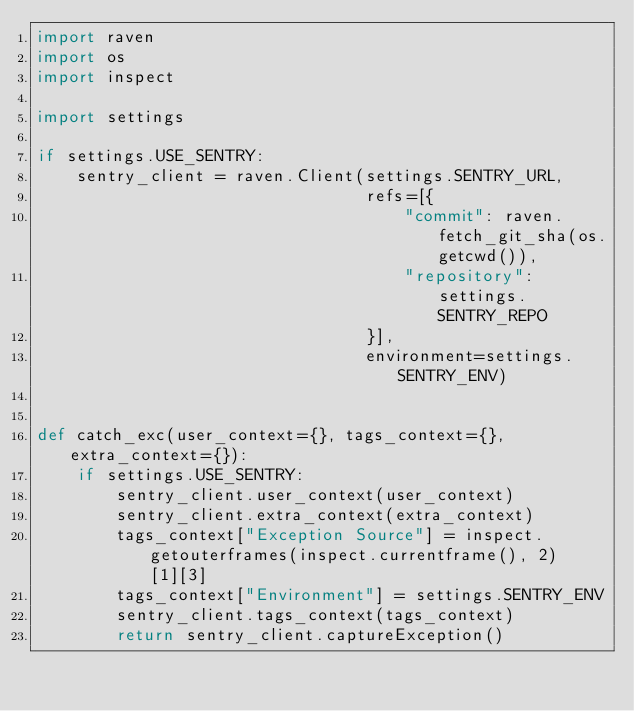<code> <loc_0><loc_0><loc_500><loc_500><_Python_>import raven
import os
import inspect

import settings

if settings.USE_SENTRY:
    sentry_client = raven.Client(settings.SENTRY_URL,
                                 refs=[{
                                     "commit": raven.fetch_git_sha(os.getcwd()),
                                     "repository": settings.SENTRY_REPO
                                 }],
                                 environment=settings.SENTRY_ENV)


def catch_exc(user_context={}, tags_context={}, extra_context={}):
    if settings.USE_SENTRY:
        sentry_client.user_context(user_context)
        sentry_client.extra_context(extra_context)
        tags_context["Exception Source"] = inspect.getouterframes(inspect.currentframe(), 2)[1][3]
        tags_context["Environment"] = settings.SENTRY_ENV
        sentry_client.tags_context(tags_context)
        return sentry_client.captureException()

</code> 